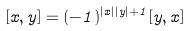<formula> <loc_0><loc_0><loc_500><loc_500>[ x , y ] = ( - 1 ) ^ { | x | | y | + 1 } [ y , x ]</formula> 